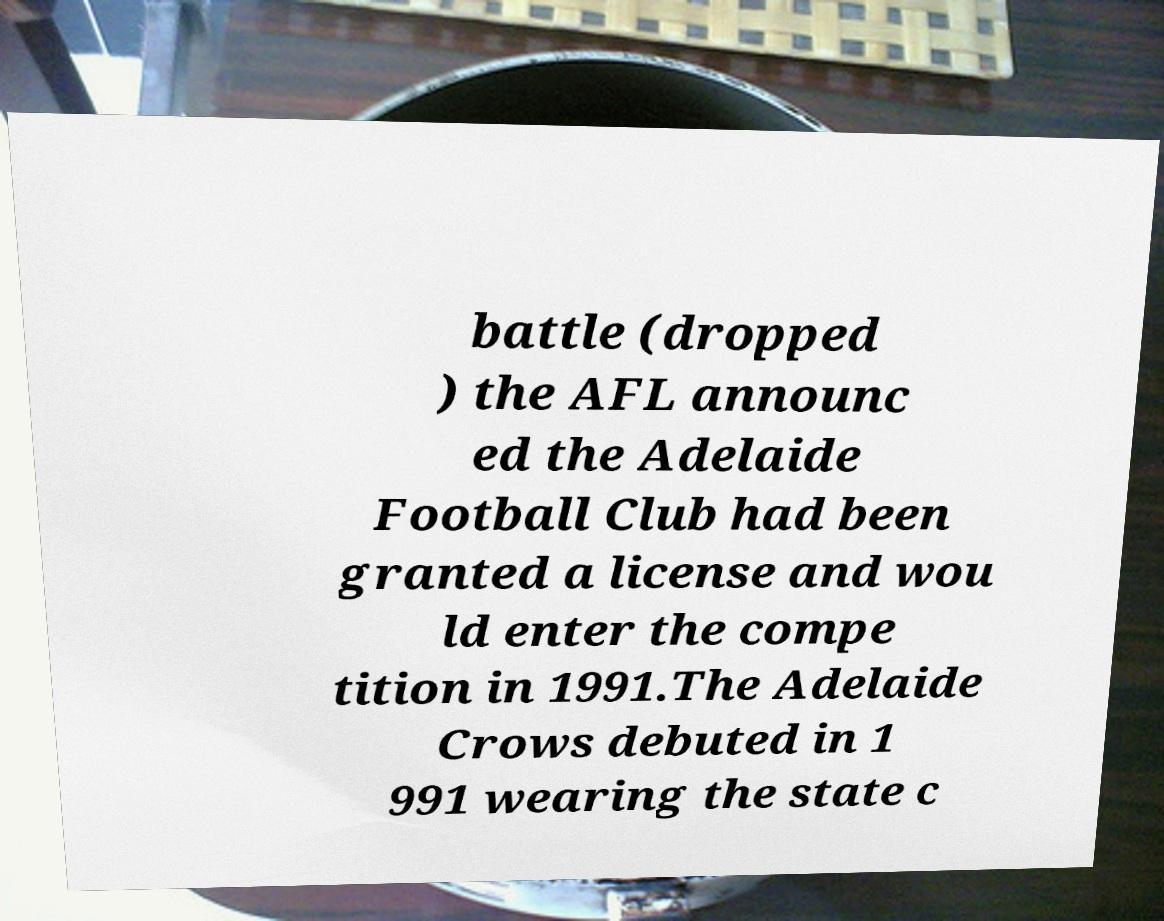What messages or text are displayed in this image? I need them in a readable, typed format. battle (dropped ) the AFL announc ed the Adelaide Football Club had been granted a license and wou ld enter the compe tition in 1991.The Adelaide Crows debuted in 1 991 wearing the state c 